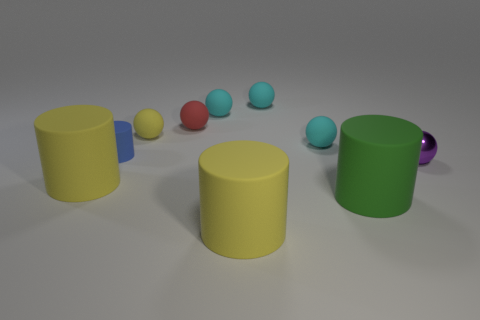How many cyan balls must be subtracted to get 2 cyan balls? 1 Subtract all small matte balls. How many balls are left? 1 Subtract 6 spheres. How many spheres are left? 0 Subtract all purple balls. Subtract all blue blocks. How many balls are left? 5 Subtract all purple balls. How many red cylinders are left? 0 Subtract all large green matte cylinders. Subtract all small cyan things. How many objects are left? 6 Add 3 cyan things. How many cyan things are left? 6 Add 7 big gray matte cylinders. How many big gray matte cylinders exist? 7 Subtract all yellow spheres. How many spheres are left? 5 Subtract 0 green spheres. How many objects are left? 10 